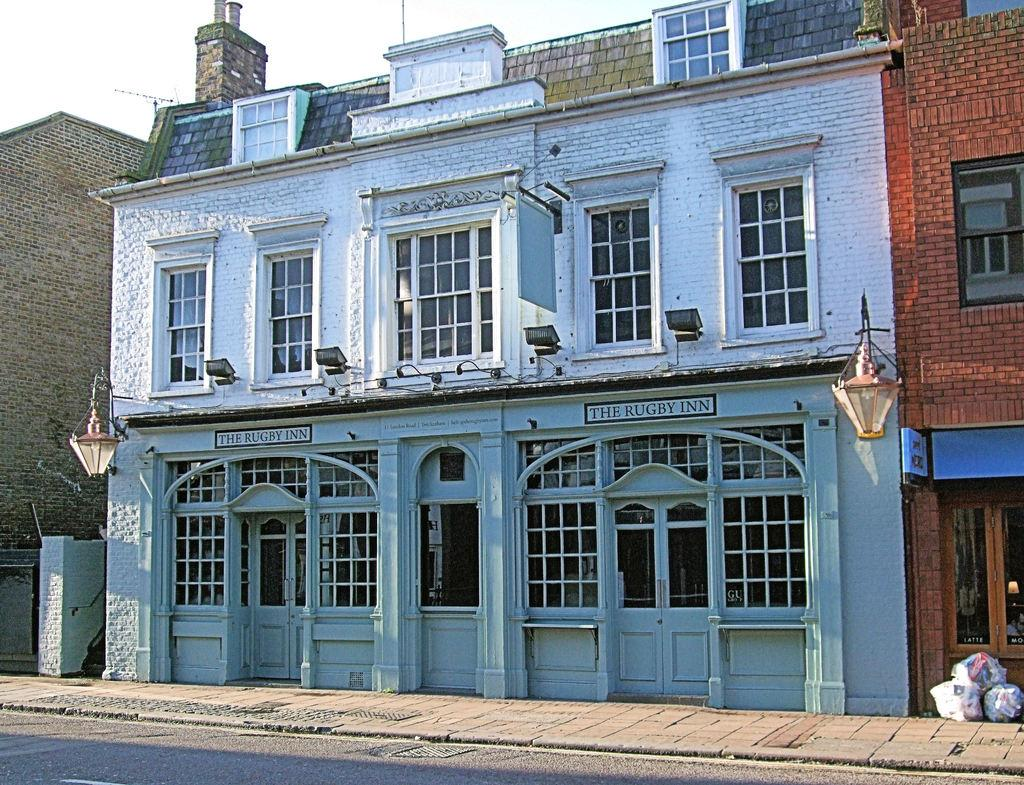What type of structures are present in the image? There are buildings in the image. What feature can be seen on the buildings? There are white doors in the image. What other architectural elements are visible on the buildings? There are windows in the image. What is visible at the top of the image? The sky is visible at the top of the image. What hobbies do the legs of the buildings engage in during the day? There are no legs present on the buildings in the image, as buildings do not have legs. 